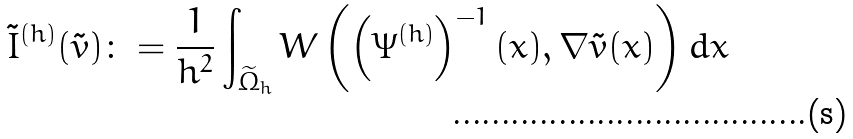Convert formula to latex. <formula><loc_0><loc_0><loc_500><loc_500>\tilde { I } ^ { ( h ) } ( \tilde { v } ) \colon = \frac { 1 } { h ^ { 2 } } \int _ { \widetilde { \Omega } _ { h } } W \left ( \left ( \Psi ^ { ( h ) } \right ) ^ { - 1 } ( x ) , \nabla \tilde { v } ( x ) \right ) d x</formula> 